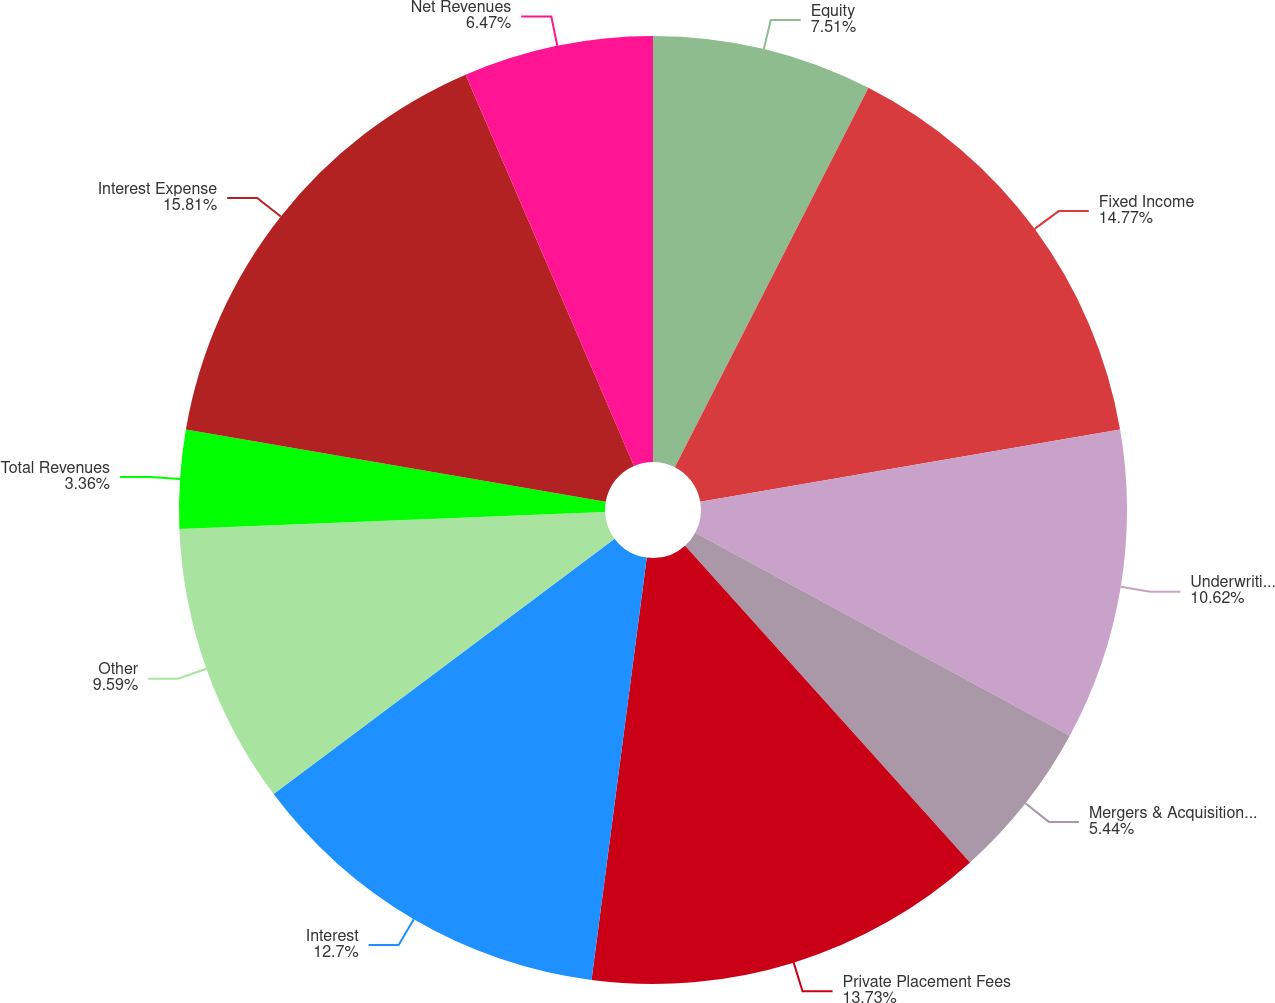<chart> <loc_0><loc_0><loc_500><loc_500><pie_chart><fcel>Equity<fcel>Fixed Income<fcel>Underwriting Fees<fcel>Mergers & Acquisitions Fees<fcel>Private Placement Fees<fcel>Interest<fcel>Other<fcel>Total Revenues<fcel>Interest Expense<fcel>Net Revenues<nl><fcel>7.51%<fcel>14.77%<fcel>10.62%<fcel>5.44%<fcel>13.73%<fcel>12.7%<fcel>9.59%<fcel>3.36%<fcel>15.81%<fcel>6.47%<nl></chart> 